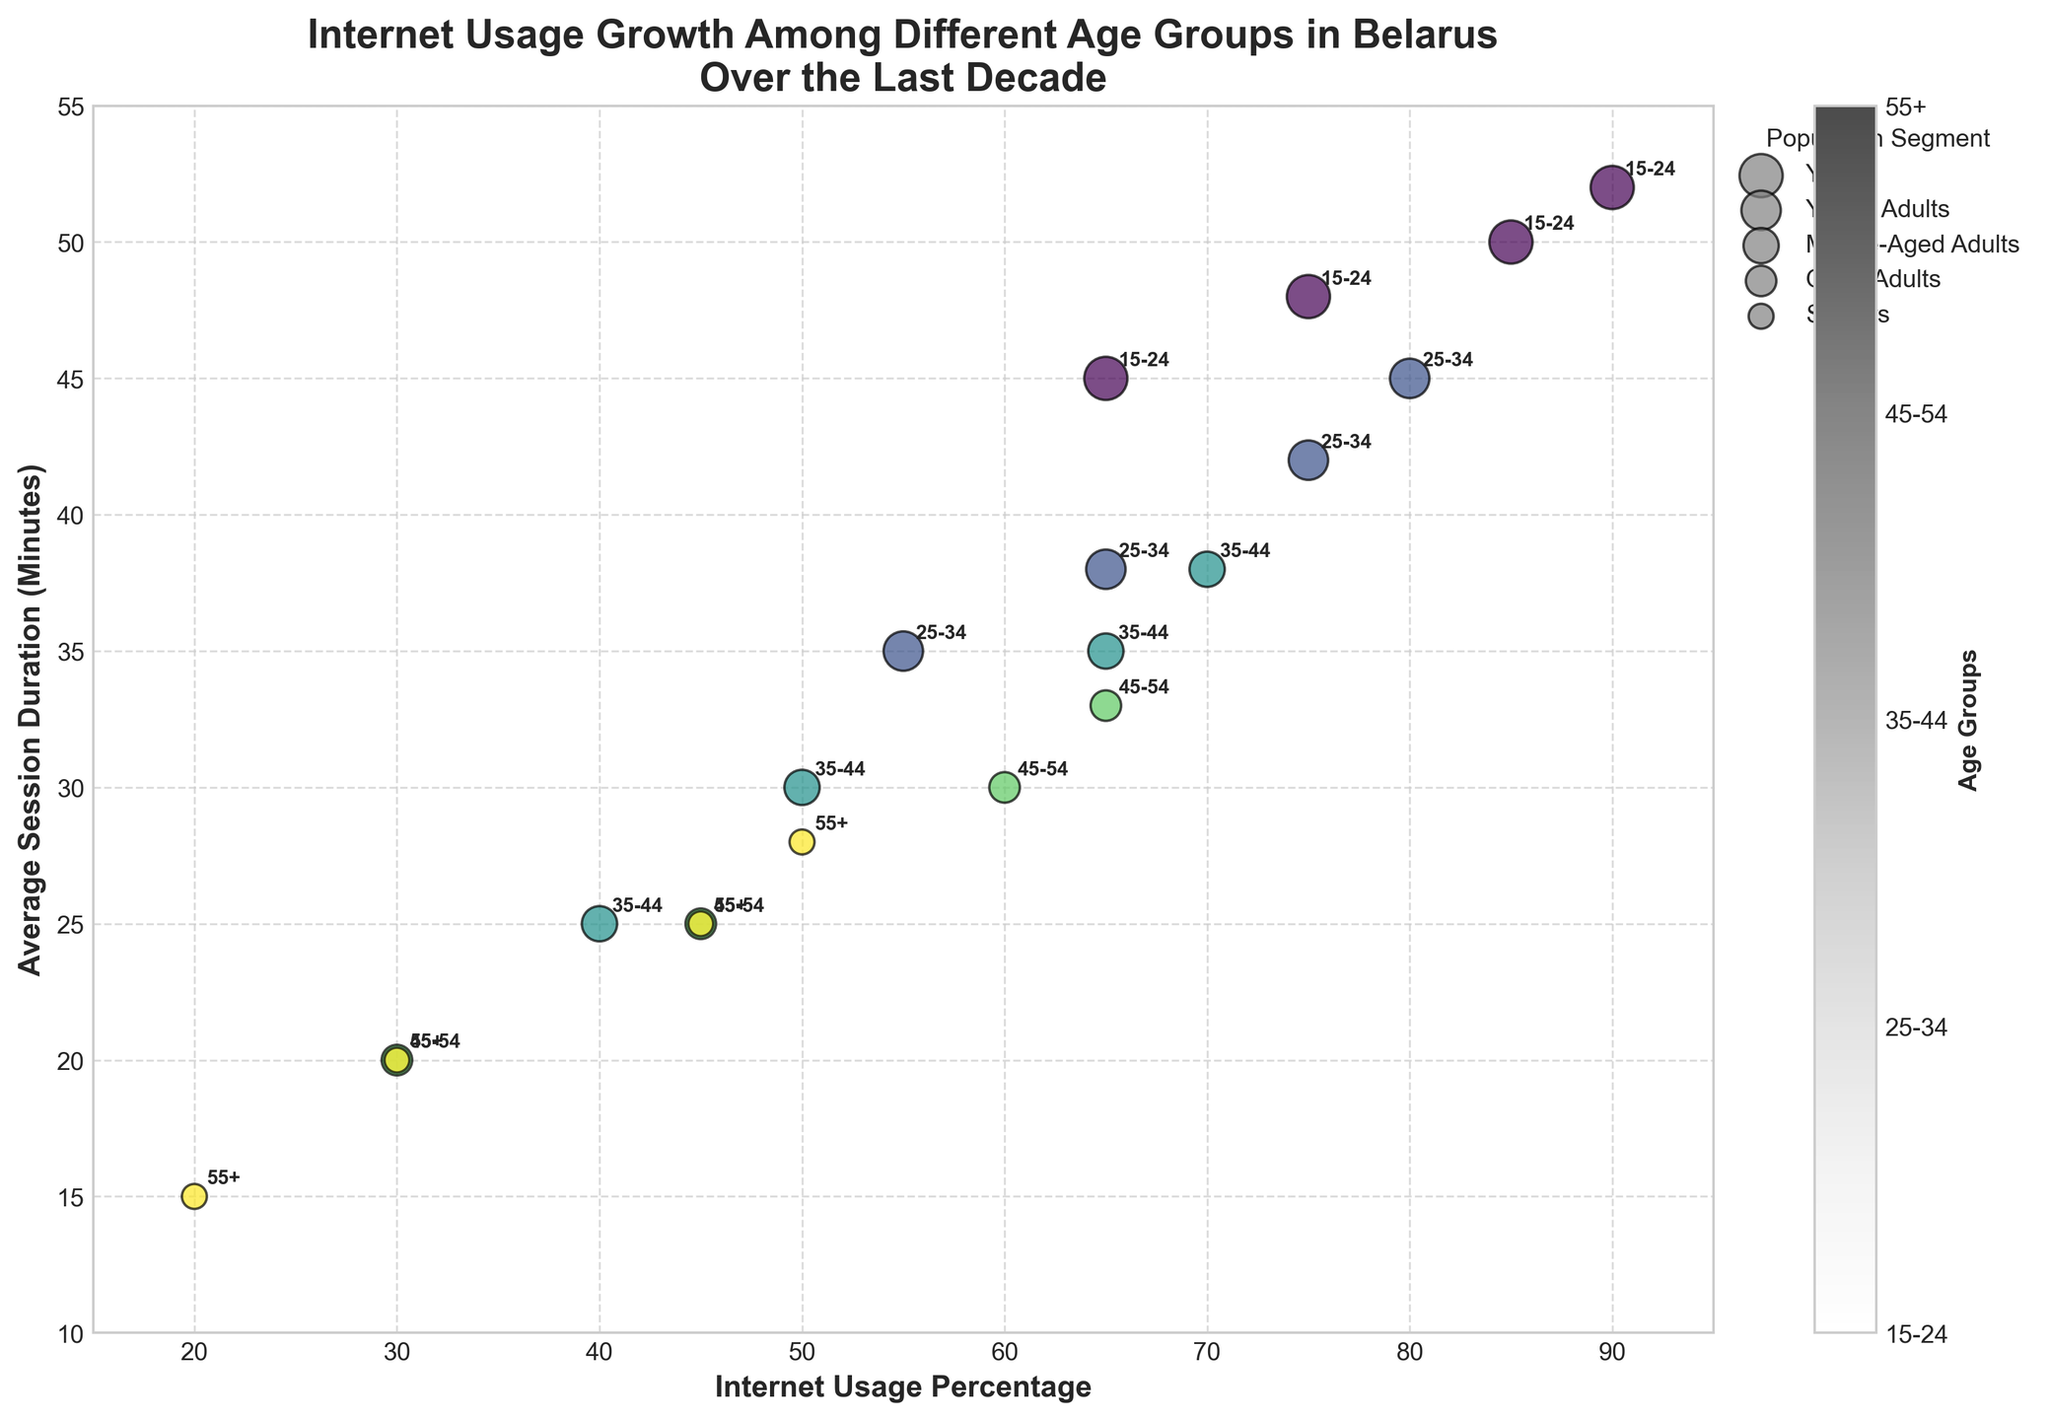What's the title of the figure? The title of the figure is mentioned at the top, describing the main topic of the chart. It reads "Internet Usage Growth Among Different Age Groups in Belarus Over the Last Decade".
Answer: Internet Usage Growth Among Different Age Groups in Belarus Over the Last Decade Which age group had the highest internet usage percentage in 2022? To determine this, look at the year 2022. Among all age groups, the one with the highest internet usage percentage can be identified by checking the x-axis for the highest value. The age group with the highest percentage is 15-24.
Answer: 15-24 How does the average session duration for the 55+ age group change from 2013 to 2022? Observe the points representing the 55+ age group from 2013 to 2022 on the y-axis, which denotes the average session duration. In 2013, it starts at 15 minutes, and by 2022, it increases to 28 minutes.
Answer: Increased from 15 to 28 minutes Which year saw the most significant increase in internet usage percentage for the 35-44 age group? Compare the internet usage percentages for the 35-44 age group across the years 2013, 2016, 2019, and 2022. The largest increase occurs between 2016 (50%) and 2019 (65%).
Answer: Between 2016 and 2019 What is the general trend of internet usage percentages across all age groups from 2013 to 2022? Look at the trend for each age group's internet usage percentages over the years. It is evident that all age groups show an increasing trend, indicating a rise in internet usage over time.
Answer: Increasing trend Which population segment is represented by the largest bubble size? The size of the bubbles indicates the population segment. The legend states that the largest bubble size (300) represents the Youth segment.
Answer: Youth In 2022, which age group had the shortest average session duration, and what was the duration? To find this, look at the data points for 2022 and check the y-axis for the shortest duration. The 55+ age group has the shortest average session duration at 28 minutes.
Answer: 55+, 28 minutes What is the difference in internet usage percentage between the 15-24 and 55+ age groups in 2022? Find the internet usage percentages for both age groups in 2022, which are 90% for 15-24 and 50% for 55+. The difference is calculated as 90% - 50% = 40%.
Answer: 40% Which age group saw a decline in internet usage percentage in any year? By observing the figures, it's clear that no age group experienced a decline in internet usage percentage over the given years. All age groups show an increase in usage percentages.
Answer: None How is the relationship between internet usage percentage and average session duration represented in the figure? Internet usage percentage is represented on the x-axis, while the average session duration is on the y-axis. Each data point (bubble) represents an age group for a given year, indicating how these two variables correlate.
Answer: Positively correlated between x and y 